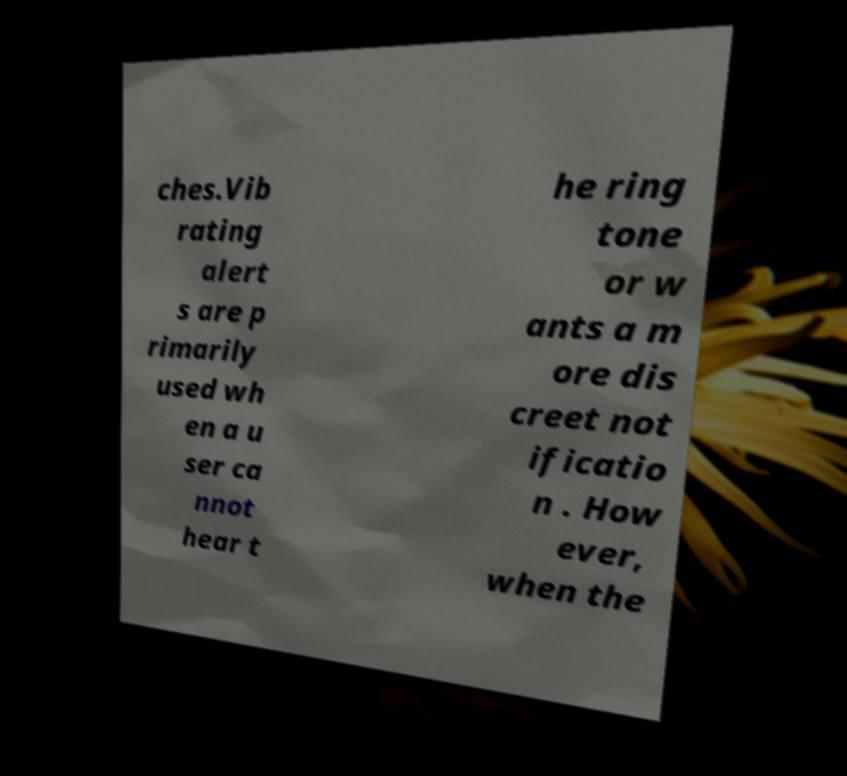Can you accurately transcribe the text from the provided image for me? ches.Vib rating alert s are p rimarily used wh en a u ser ca nnot hear t he ring tone or w ants a m ore dis creet not ificatio n . How ever, when the 